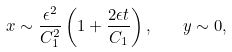Convert formula to latex. <formula><loc_0><loc_0><loc_500><loc_500>x \sim \frac { \epsilon ^ { 2 } } { C _ { 1 } ^ { 2 } } \left ( 1 + \frac { 2 \epsilon t } { C _ { 1 } } \right ) , \quad y \sim 0 ,</formula> 